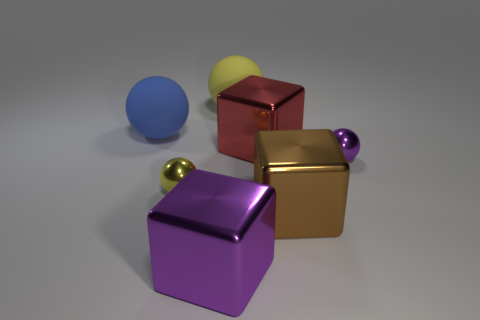Does the brown shiny thing have the same shape as the big blue thing?
Make the answer very short. No. What is the color of the other rubber sphere that is the same size as the blue rubber ball?
Your response must be concise. Yellow. The blue rubber thing that is the same shape as the small yellow thing is what size?
Provide a succinct answer. Large. The tiny thing that is left of the yellow matte sphere has what shape?
Your answer should be compact. Sphere. There is a tiny yellow thing; does it have the same shape as the small purple shiny object on the right side of the red thing?
Provide a succinct answer. Yes. Are there an equal number of big blue rubber things right of the purple metal cube and brown metallic blocks that are behind the big yellow rubber object?
Offer a very short reply. Yes. There is a large ball right of the blue object; is it the same color as the metal sphere on the left side of the large yellow matte ball?
Your response must be concise. Yes. Are there more blocks that are on the left side of the brown metal cube than blue rubber objects?
Give a very brief answer. Yes. What is the material of the large yellow thing?
Your response must be concise. Rubber. The other object that is made of the same material as the large yellow object is what shape?
Give a very brief answer. Sphere. 